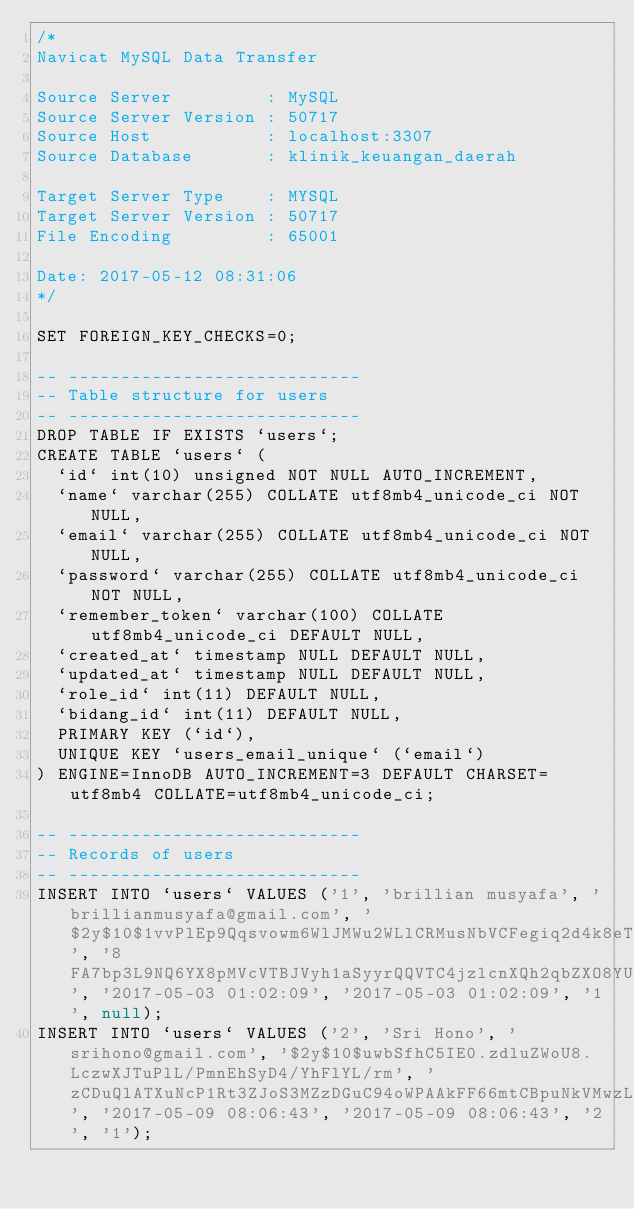Convert code to text. <code><loc_0><loc_0><loc_500><loc_500><_SQL_>/*
Navicat MySQL Data Transfer

Source Server         : MySQL
Source Server Version : 50717
Source Host           : localhost:3307
Source Database       : klinik_keuangan_daerah

Target Server Type    : MYSQL
Target Server Version : 50717
File Encoding         : 65001

Date: 2017-05-12 08:31:06
*/

SET FOREIGN_KEY_CHECKS=0;

-- ----------------------------
-- Table structure for users
-- ----------------------------
DROP TABLE IF EXISTS `users`;
CREATE TABLE `users` (
  `id` int(10) unsigned NOT NULL AUTO_INCREMENT,
  `name` varchar(255) COLLATE utf8mb4_unicode_ci NOT NULL,
  `email` varchar(255) COLLATE utf8mb4_unicode_ci NOT NULL,
  `password` varchar(255) COLLATE utf8mb4_unicode_ci NOT NULL,
  `remember_token` varchar(100) COLLATE utf8mb4_unicode_ci DEFAULT NULL,
  `created_at` timestamp NULL DEFAULT NULL,
  `updated_at` timestamp NULL DEFAULT NULL,
  `role_id` int(11) DEFAULT NULL,
  `bidang_id` int(11) DEFAULT NULL,
  PRIMARY KEY (`id`),
  UNIQUE KEY `users_email_unique` (`email`)
) ENGINE=InnoDB AUTO_INCREMENT=3 DEFAULT CHARSET=utf8mb4 COLLATE=utf8mb4_unicode_ci;

-- ----------------------------
-- Records of users
-- ----------------------------
INSERT INTO `users` VALUES ('1', 'brillian musyafa', 'brillianmusyafa@gmail.com', '$2y$10$1vvPlEp9Qqsvowm6WlJMWu2WLlCRMusNbVCFegiq2d4k8eT1dFrV2', '8FA7bp3L9NQ6YX8pMVcVTBJVyh1aSyyrQQVTC4jzlcnXQh2qbZXO8YUCeDaw', '2017-05-03 01:02:09', '2017-05-03 01:02:09', '1', null);
INSERT INTO `users` VALUES ('2', 'Sri Hono', 'srihono@gmail.com', '$2y$10$uwbSfhC5IE0.zdluZWoU8.LczwXJTuPlL/PmnEhSyD4/YhFlYL/rm', 'zCDuQlATXuNcP1Rt3ZJoS3MZzDGuC94oWPAAkFF66mtCBpuNkVMwzLvgw2gB', '2017-05-09 08:06:43', '2017-05-09 08:06:43', '2', '1');
</code> 